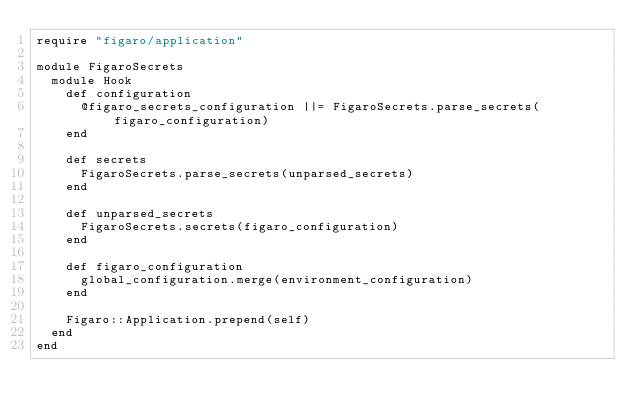<code> <loc_0><loc_0><loc_500><loc_500><_Ruby_>require "figaro/application"

module FigaroSecrets
  module Hook
    def configuration
      @figaro_secrets_configuration ||= FigaroSecrets.parse_secrets(figaro_configuration)
    end

    def secrets
      FigaroSecrets.parse_secrets(unparsed_secrets)
    end

    def unparsed_secrets
      FigaroSecrets.secrets(figaro_configuration)
    end

    def figaro_configuration
      global_configuration.merge(environment_configuration)
    end

    Figaro::Application.prepend(self)
  end
end
</code> 